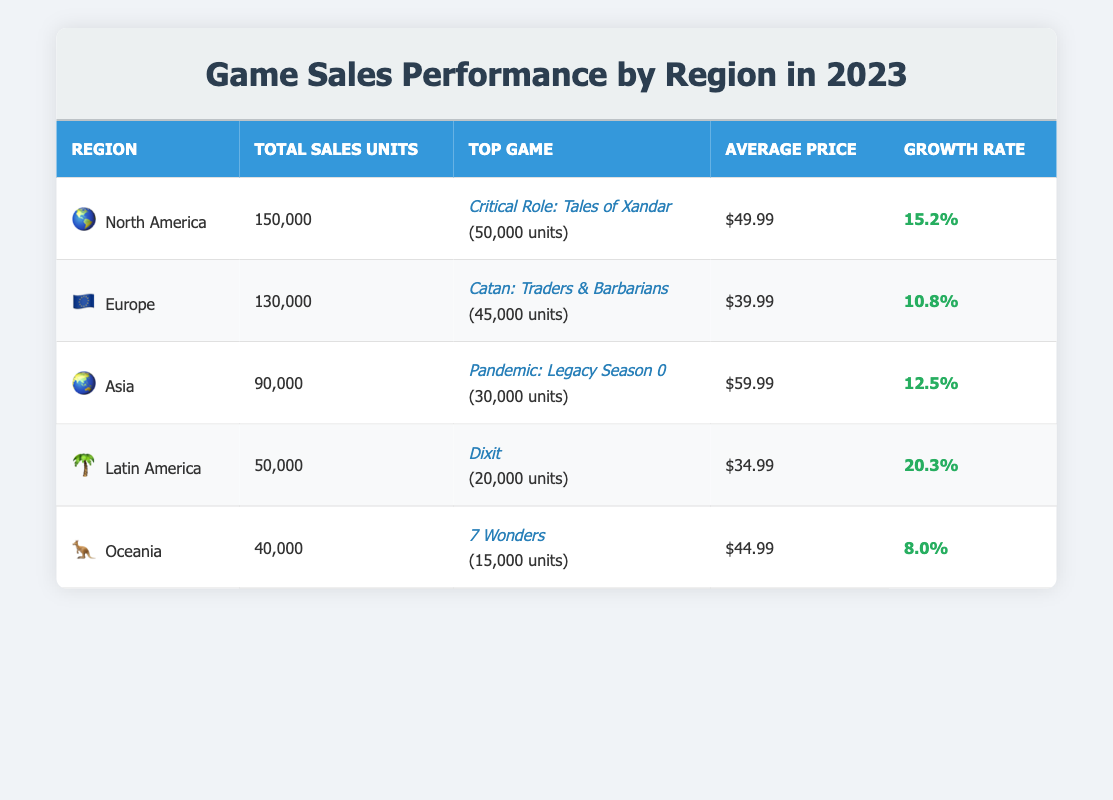What is the total sales units for North America? From the table, the total sales units for North America is listed under the "Total Sales Units" column, which shows 150,000.
Answer: 150000 Which game had the highest sales units in Europe? According to the table, the top game in Europe is "Catan: Traders & Barbarians" with sales units of 45,000, as indicated in the "Top Game" column.
Answer: Catan: Traders & Barbarians What is the average price of games in Asia? The average price for games in Asia is found in the "Average Price" column, which states $59.99.
Answer: 59.99 Was the growth rate for Latin America higher than that of Oceania? By comparing the growth rates, Latin America has a growth rate of 20.3%, while Oceania's growth rate is 8.0%. Therefore, the growth rate for Latin America is indeed higher.
Answer: Yes What is the sum of total sales units for North America and Europe? To find the sum, we take the total sales units for North America (150,000) and for Europe (130,000) and add them together: 150,000 + 130,000 = 280,000.
Answer: 280000 Which region has the lowest total sales units? Examining the "Total Sales Units" column, Oceania has the lowest total sales units at 40,000.
Answer: Oceania What percentage of total sales units in Asia does the top game represent? The top game in Asia, "Pandemic: Legacy Season 0," sold 30,000 units. To find the percentage, we divide the top game sales by the total sales units for Asia: (30,000 / 90,000) * 100 = 33.33%.
Answer: 33.33 Does Europe have a higher average price than Latin America? From the table, Europe has an average price of $39.99, while Latin America has an average price of $34.99. Since $39.99 is greater than $34.99, Europe does have a higher average price.
Answer: Yes What is the difference in total sales units between North America and Asia? The total sales units for North America is 150,000 while for Asia it is 90,000. The difference is calculated as 150,000 - 90,000 = 60,000.
Answer: 60000 